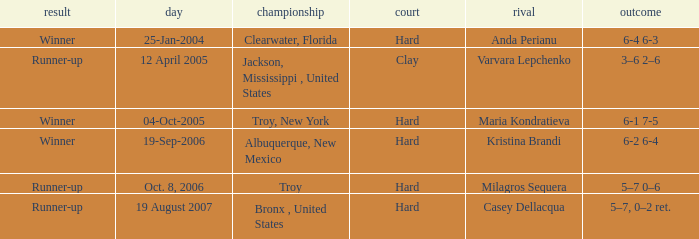What is the score of the game that was played against Maria Kondratieva? 6-1 7-5. 